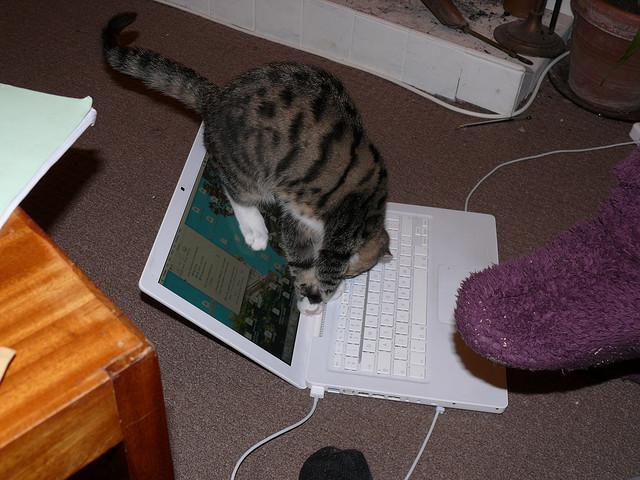Evaluate: Does the caption "The person is facing the dining table." match the image?
Answer yes or no. No. 